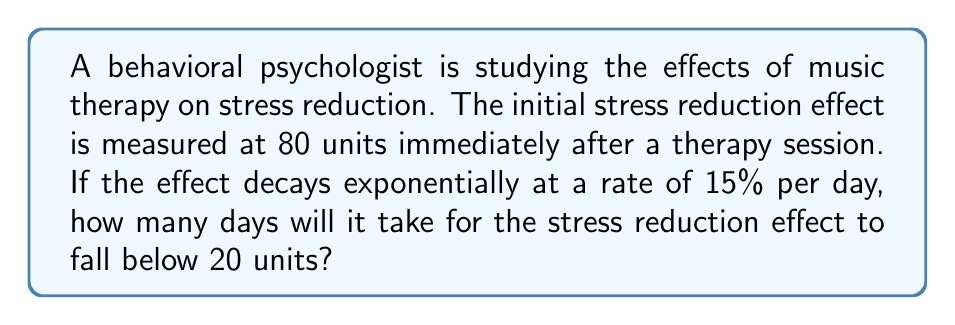Teach me how to tackle this problem. Let's approach this step-by-step using the exponential decay formula:

1) The exponential decay formula is:
   $A(t) = A_0 \cdot (1-r)^t$

   Where:
   $A(t)$ is the amount at time $t$
   $A_0$ is the initial amount
   $r$ is the decay rate
   $t$ is the time

2) We're given:
   $A_0 = 80$ (initial effect)
   $r = 0.15$ (15% decay rate)
   We want to find $t$ when $A(t) < 20$

3) Let's set up the equation:
   $20 = 80 \cdot (1-0.15)^t$

4) Simplify:
   $20 = 80 \cdot (0.85)^t$

5) Divide both sides by 80:
   $\frac{1}{4} = (0.85)^t$

6) Take the natural log of both sides:
   $\ln(\frac{1}{4}) = \ln((0.85)^t)$

7) Use the logarithm property $\ln(a^b) = b\ln(a)$:
   $\ln(\frac{1}{4}) = t \cdot \ln(0.85)$

8) Solve for $t$:
   $t = \frac{\ln(\frac{1}{4})}{\ln(0.85)}$

9) Calculate:
   $t \approx 8.7853$

10) Since we can't have a fraction of a day, we round up to the next whole number.
Answer: 9 days 